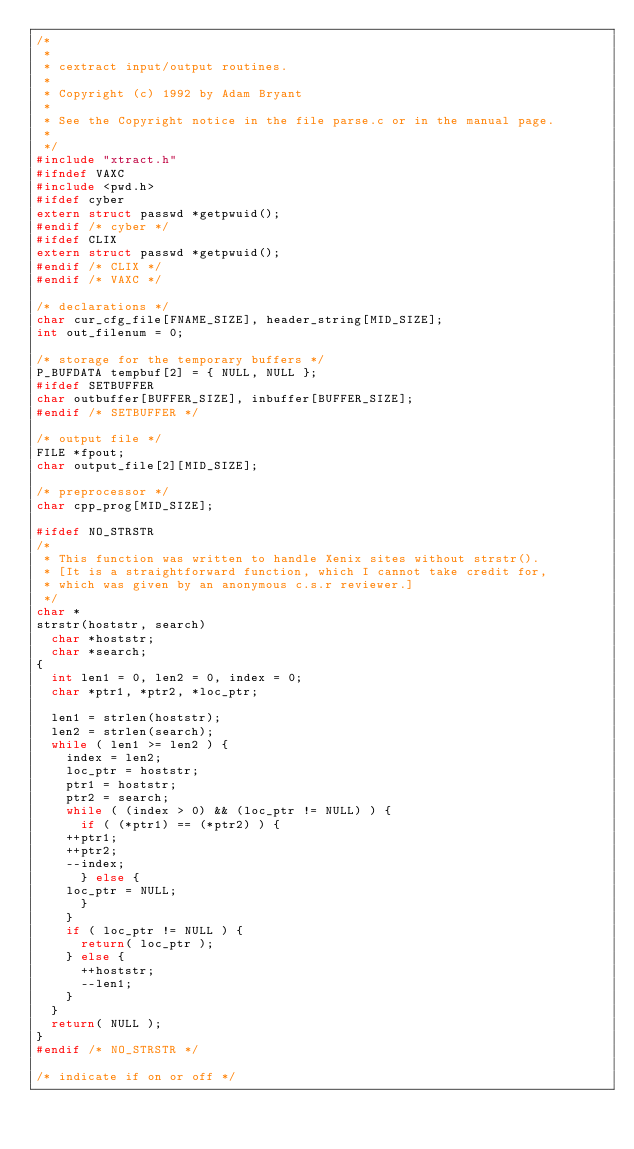Convert code to text. <code><loc_0><loc_0><loc_500><loc_500><_C_>/*
 *
 * cextract input/output routines.
 *
 * Copyright (c) 1992 by Adam Bryant
 *
 * See the Copyright notice in the file parse.c or in the manual page.
 *
 */
#include "xtract.h"
#ifndef VAXC
#include <pwd.h>
#ifdef cyber
extern struct passwd *getpwuid();
#endif /* cyber */
#ifdef CLIX
extern struct passwd *getpwuid();
#endif /* CLIX */
#endif /* VAXC */

/* declarations */
char cur_cfg_file[FNAME_SIZE], header_string[MID_SIZE];
int out_filenum = 0;

/* storage for the temporary buffers */
P_BUFDATA tempbuf[2] = { NULL, NULL };
#ifdef SETBUFFER
char outbuffer[BUFFER_SIZE], inbuffer[BUFFER_SIZE];
#endif /* SETBUFFER */

/* output file */
FILE *fpout;
char output_file[2][MID_SIZE];

/* preprocessor */
char cpp_prog[MID_SIZE];

#ifdef NO_STRSTR
/*
 * This function was written to handle Xenix sites without strstr().
 * [It is a straightforward function, which I cannot take credit for,
 * which was given by an anonymous c.s.r reviewer.]
 */
char *
strstr(hoststr, search)
  char *hoststr;
  char *search;
{
  int len1 = 0, len2 = 0, index = 0;
  char *ptr1, *ptr2, *loc_ptr;

  len1 = strlen(hoststr);
  len2 = strlen(search);
  while ( len1 >= len2 ) {
    index = len2;
    loc_ptr = hoststr;
    ptr1 = hoststr;
    ptr2 = search;
    while ( (index > 0) && (loc_ptr != NULL) ) {
      if ( (*ptr1) == (*ptr2) ) {
	++ptr1;
	++ptr2;
	--index;
      } else {
	loc_ptr = NULL;
      }
    }
    if ( loc_ptr != NULL ) {
      return( loc_ptr );
    } else {
      ++hoststr;
      --len1;
    }
  }
  return( NULL );
}
#endif /* NO_STRSTR */

/* indicate if on or off */</code> 